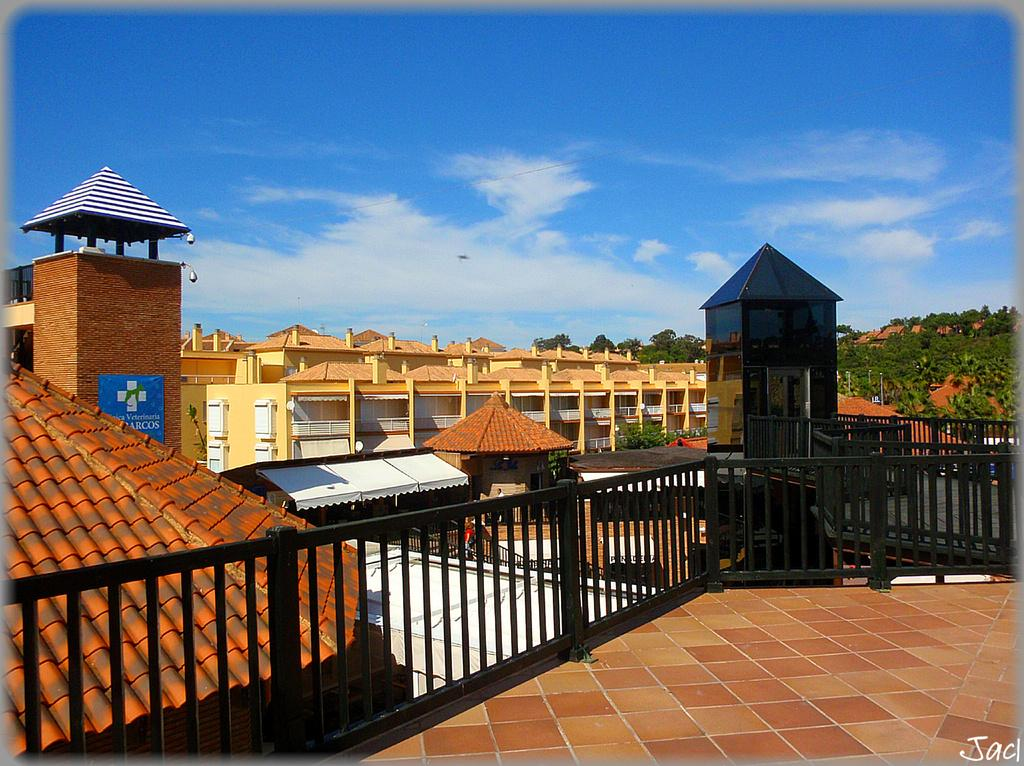What is located in the foreground of the image? There is a terrace and a fence in the foreground of the image. What structures can be seen in the image? There are buildings visible in the image. What type of natural elements are present in the foreground of the image? Trees are present in the foreground of the image. What type of landscape feature is visible in the background of the image? Mountains are visible in the image. What is visible at the top of the image? The sky is visible at the top of the image. When was the image taken? The image was taken during the day. What type of tax is being discussed in the image? There is no discussion of tax in the image; it features a terrace, fence, buildings, trees, mountains, sky, and was taken during the day. What type of dirt is visible on the terrace in the image? There is no dirt visible on the terrace in the image; it appears to be clean and well-maintained. 